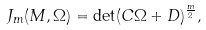<formula> <loc_0><loc_0><loc_500><loc_500>J _ { m } ( M , \Omega ) = \det ( C \Omega + D ) ^ { \frac { m } { 2 } } ,</formula> 